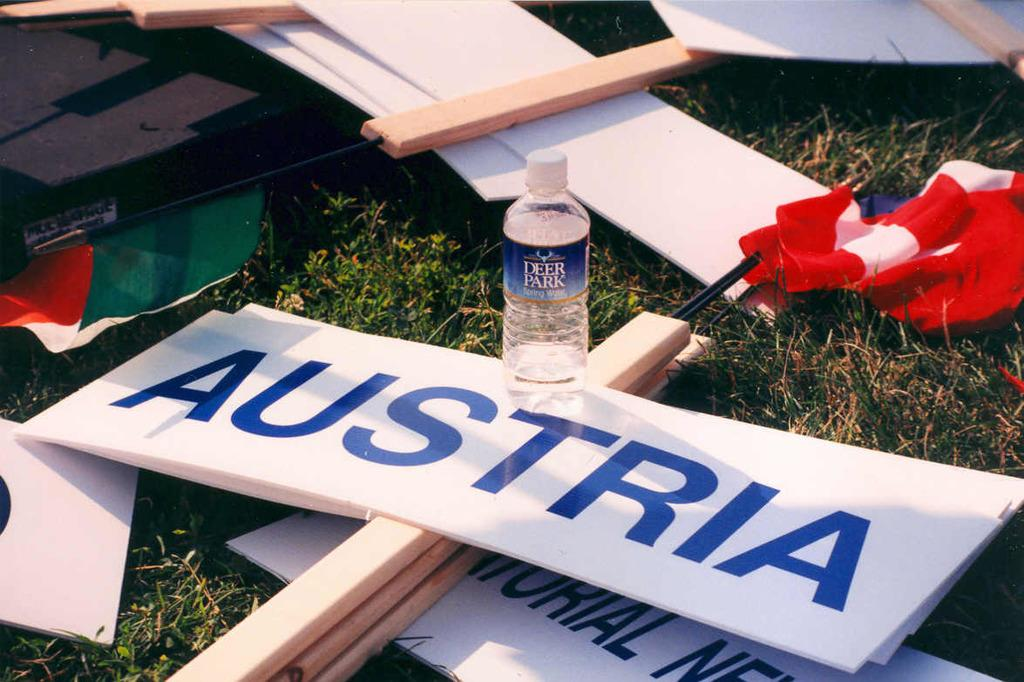What objects are present in the image that are made of wood or a similar material? There are boards in the image. What objects in the image represent a country or organization? There are flags in the image. What type of container is visible in the image? There is a bottle in the image. What color is the grass in the image? The grass in the image is green. What sound can be heard coming from the bottle in the image? There is no sound coming from the bottle in the image, as it is a static picture. Who is the manager of the team represented by the flags in the image? The image does not provide information about any teams or their managers. 